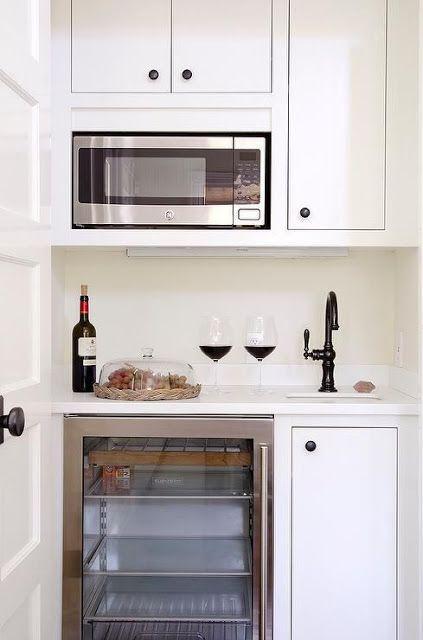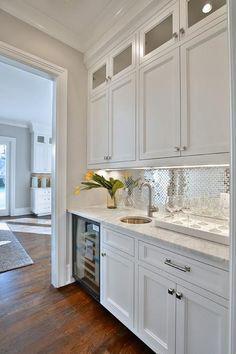The first image is the image on the left, the second image is the image on the right. Analyze the images presented: Is the assertion "There is a stainless steel refrigerator  next to an entryway." valid? Answer yes or no. No. The first image is the image on the left, the second image is the image on the right. Considering the images on both sides, is "An image shows a kitchen with white cabinets and a stainless steel refrigerator with """"french doors""""." valid? Answer yes or no. No. 